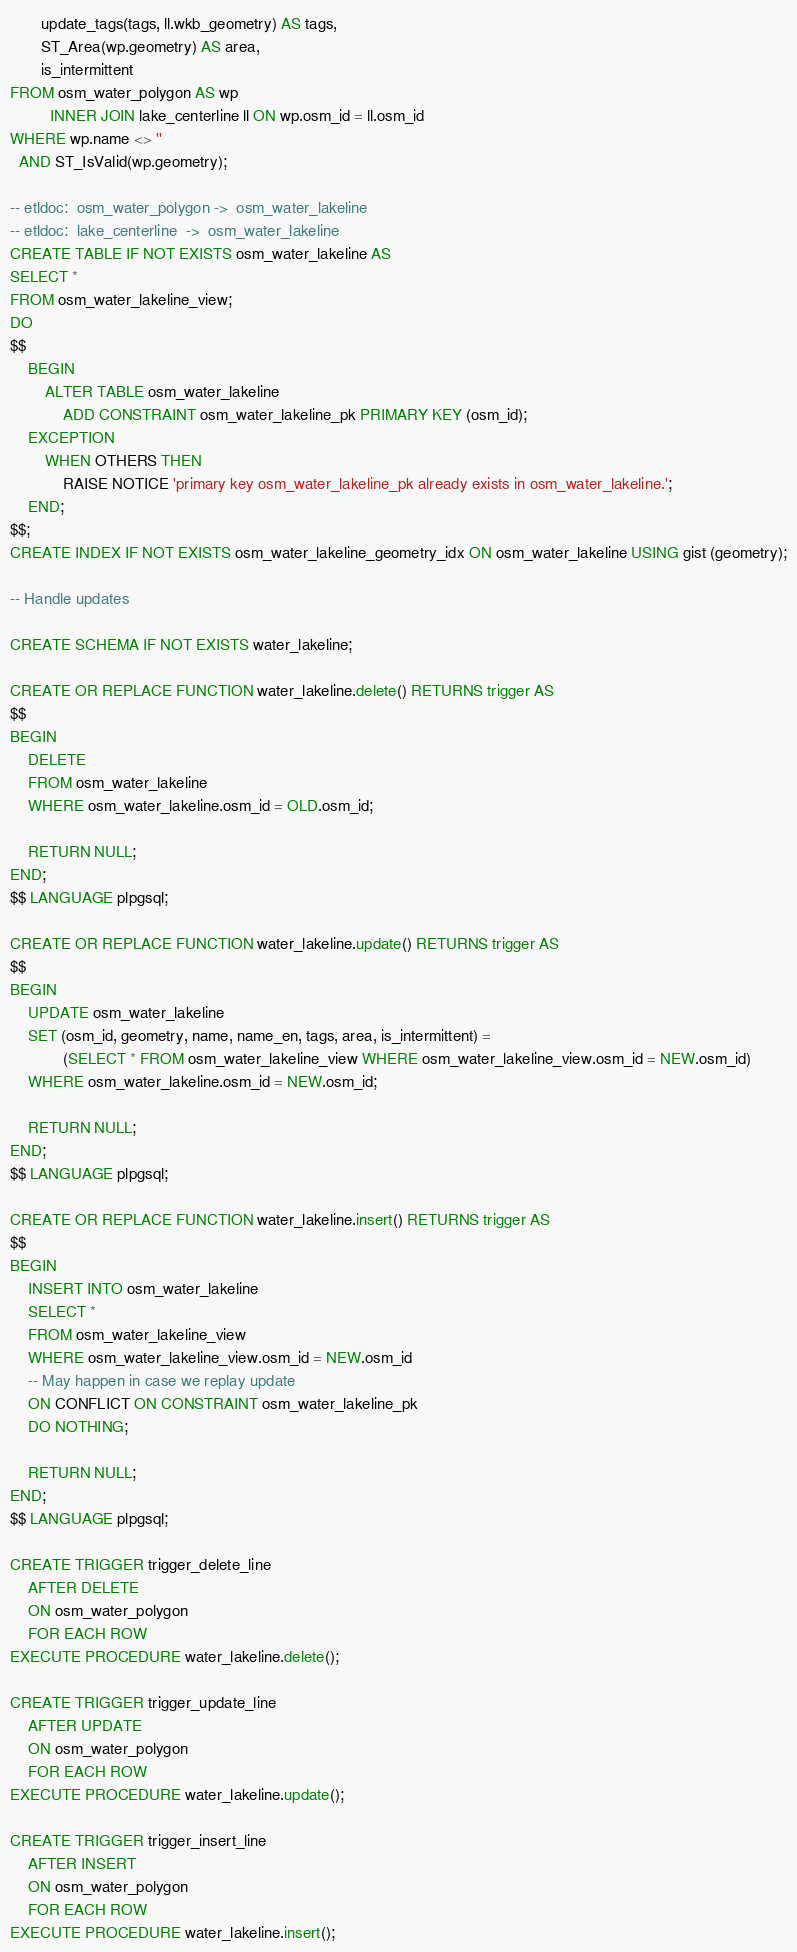<code> <loc_0><loc_0><loc_500><loc_500><_SQL_>       update_tags(tags, ll.wkb_geometry) AS tags,
       ST_Area(wp.geometry) AS area,
       is_intermittent
FROM osm_water_polygon AS wp
         INNER JOIN lake_centerline ll ON wp.osm_id = ll.osm_id
WHERE wp.name <> ''
  AND ST_IsValid(wp.geometry);

-- etldoc:  osm_water_polygon ->  osm_water_lakeline
-- etldoc:  lake_centerline  ->  osm_water_lakeline
CREATE TABLE IF NOT EXISTS osm_water_lakeline AS
SELECT *
FROM osm_water_lakeline_view;
DO
$$
    BEGIN
        ALTER TABLE osm_water_lakeline
            ADD CONSTRAINT osm_water_lakeline_pk PRIMARY KEY (osm_id);
    EXCEPTION
        WHEN OTHERS THEN
            RAISE NOTICE 'primary key osm_water_lakeline_pk already exists in osm_water_lakeline.';
    END;
$$;
CREATE INDEX IF NOT EXISTS osm_water_lakeline_geometry_idx ON osm_water_lakeline USING gist (geometry);

-- Handle updates

CREATE SCHEMA IF NOT EXISTS water_lakeline;

CREATE OR REPLACE FUNCTION water_lakeline.delete() RETURNS trigger AS
$$
BEGIN
    DELETE
    FROM osm_water_lakeline
    WHERE osm_water_lakeline.osm_id = OLD.osm_id;

    RETURN NULL;
END;
$$ LANGUAGE plpgsql;

CREATE OR REPLACE FUNCTION water_lakeline.update() RETURNS trigger AS
$$
BEGIN
    UPDATE osm_water_lakeline
    SET (osm_id, geometry, name, name_en, tags, area, is_intermittent) =
            (SELECT * FROM osm_water_lakeline_view WHERE osm_water_lakeline_view.osm_id = NEW.osm_id)
    WHERE osm_water_lakeline.osm_id = NEW.osm_id;

    RETURN NULL;
END;
$$ LANGUAGE plpgsql;

CREATE OR REPLACE FUNCTION water_lakeline.insert() RETURNS trigger AS
$$
BEGIN
    INSERT INTO osm_water_lakeline
    SELECT *
    FROM osm_water_lakeline_view
    WHERE osm_water_lakeline_view.osm_id = NEW.osm_id
    -- May happen in case we replay update
    ON CONFLICT ON CONSTRAINT osm_water_lakeline_pk
    DO NOTHING;

    RETURN NULL;
END;
$$ LANGUAGE plpgsql;

CREATE TRIGGER trigger_delete_line
    AFTER DELETE
    ON osm_water_polygon
    FOR EACH ROW
EXECUTE PROCEDURE water_lakeline.delete();

CREATE TRIGGER trigger_update_line
    AFTER UPDATE
    ON osm_water_polygon
    FOR EACH ROW
EXECUTE PROCEDURE water_lakeline.update();

CREATE TRIGGER trigger_insert_line
    AFTER INSERT
    ON osm_water_polygon
    FOR EACH ROW
EXECUTE PROCEDURE water_lakeline.insert();
</code> 